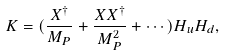<formula> <loc_0><loc_0><loc_500><loc_500>K = ( \frac { X ^ { \dagger } } { M _ { P } } + \frac { X X ^ { \dagger } } { M _ { P } ^ { 2 } } + \cdots ) H _ { u } H _ { d } ,</formula> 